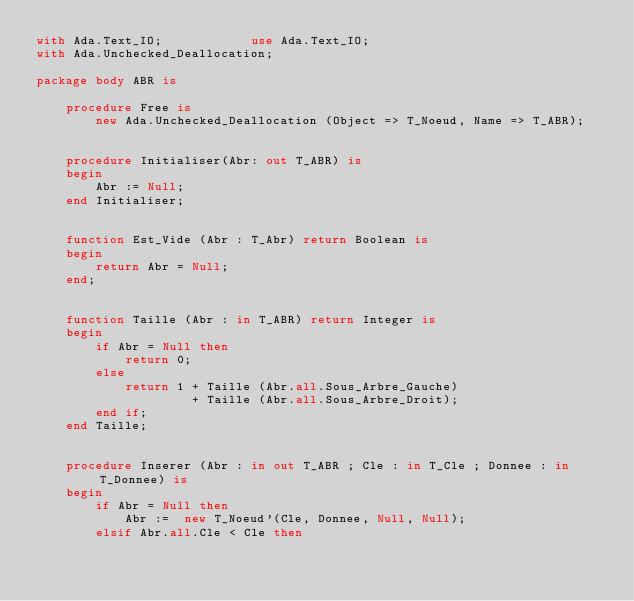Convert code to text. <code><loc_0><loc_0><loc_500><loc_500><_Ada_>with Ada.Text_IO;            use Ada.Text_IO;
with Ada.Unchecked_Deallocation;

package body ABR is

	procedure Free is
		new Ada.Unchecked_Deallocation (Object => T_Noeud, Name => T_ABR);


	procedure Initialiser(Abr: out T_ABR) is
	begin
		Abr := Null;
	end Initialiser;


	function Est_Vide (Abr : T_Abr) return Boolean is
	begin
		return Abr = Null;
	end;


	function Taille (Abr : in T_ABR) return Integer is
	begin
		if Abr = Null then
			return 0;
		else
			return 1 + Taille (Abr.all.Sous_Arbre_Gauche)
					 + Taille (Abr.all.Sous_Arbre_Droit);
		end if;
	end Taille;


	procedure Inserer (Abr : in out T_ABR ; Cle : in T_Cle ; Donnee : in T_Donnee) is
	begin
		if Abr = Null then
			Abr :=  new T_Noeud'(Cle, Donnee, Null, Null);
		elsif Abr.all.Cle < Cle then</code> 